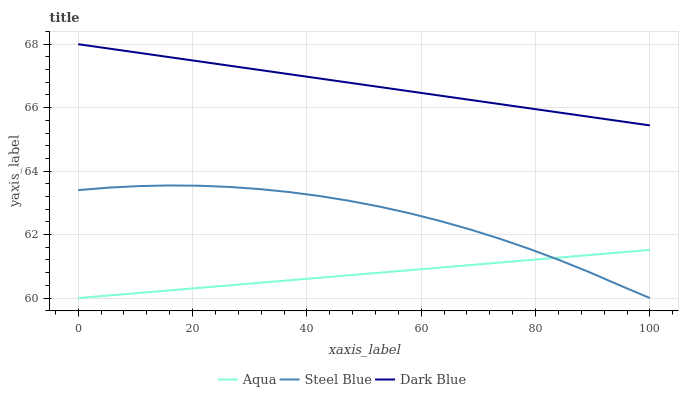Does Aqua have the minimum area under the curve?
Answer yes or no. Yes. Does Dark Blue have the maximum area under the curve?
Answer yes or no. Yes. Does Steel Blue have the minimum area under the curve?
Answer yes or no. No. Does Steel Blue have the maximum area under the curve?
Answer yes or no. No. Is Aqua the smoothest?
Answer yes or no. Yes. Is Steel Blue the roughest?
Answer yes or no. Yes. Is Steel Blue the smoothest?
Answer yes or no. No. Is Aqua the roughest?
Answer yes or no. No. Does Aqua have the lowest value?
Answer yes or no. Yes. Does Dark Blue have the highest value?
Answer yes or no. Yes. Does Steel Blue have the highest value?
Answer yes or no. No. Is Aqua less than Dark Blue?
Answer yes or no. Yes. Is Dark Blue greater than Steel Blue?
Answer yes or no. Yes. Does Steel Blue intersect Aqua?
Answer yes or no. Yes. Is Steel Blue less than Aqua?
Answer yes or no. No. Is Steel Blue greater than Aqua?
Answer yes or no. No. Does Aqua intersect Dark Blue?
Answer yes or no. No. 